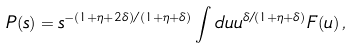Convert formula to latex. <formula><loc_0><loc_0><loc_500><loc_500>P ( s ) = s ^ { - ( 1 + \eta + 2 \delta ) / ( 1 + \eta + \delta ) } \int d u u ^ { \delta / ( 1 + \eta + \delta ) } F ( u ) \, ,</formula> 